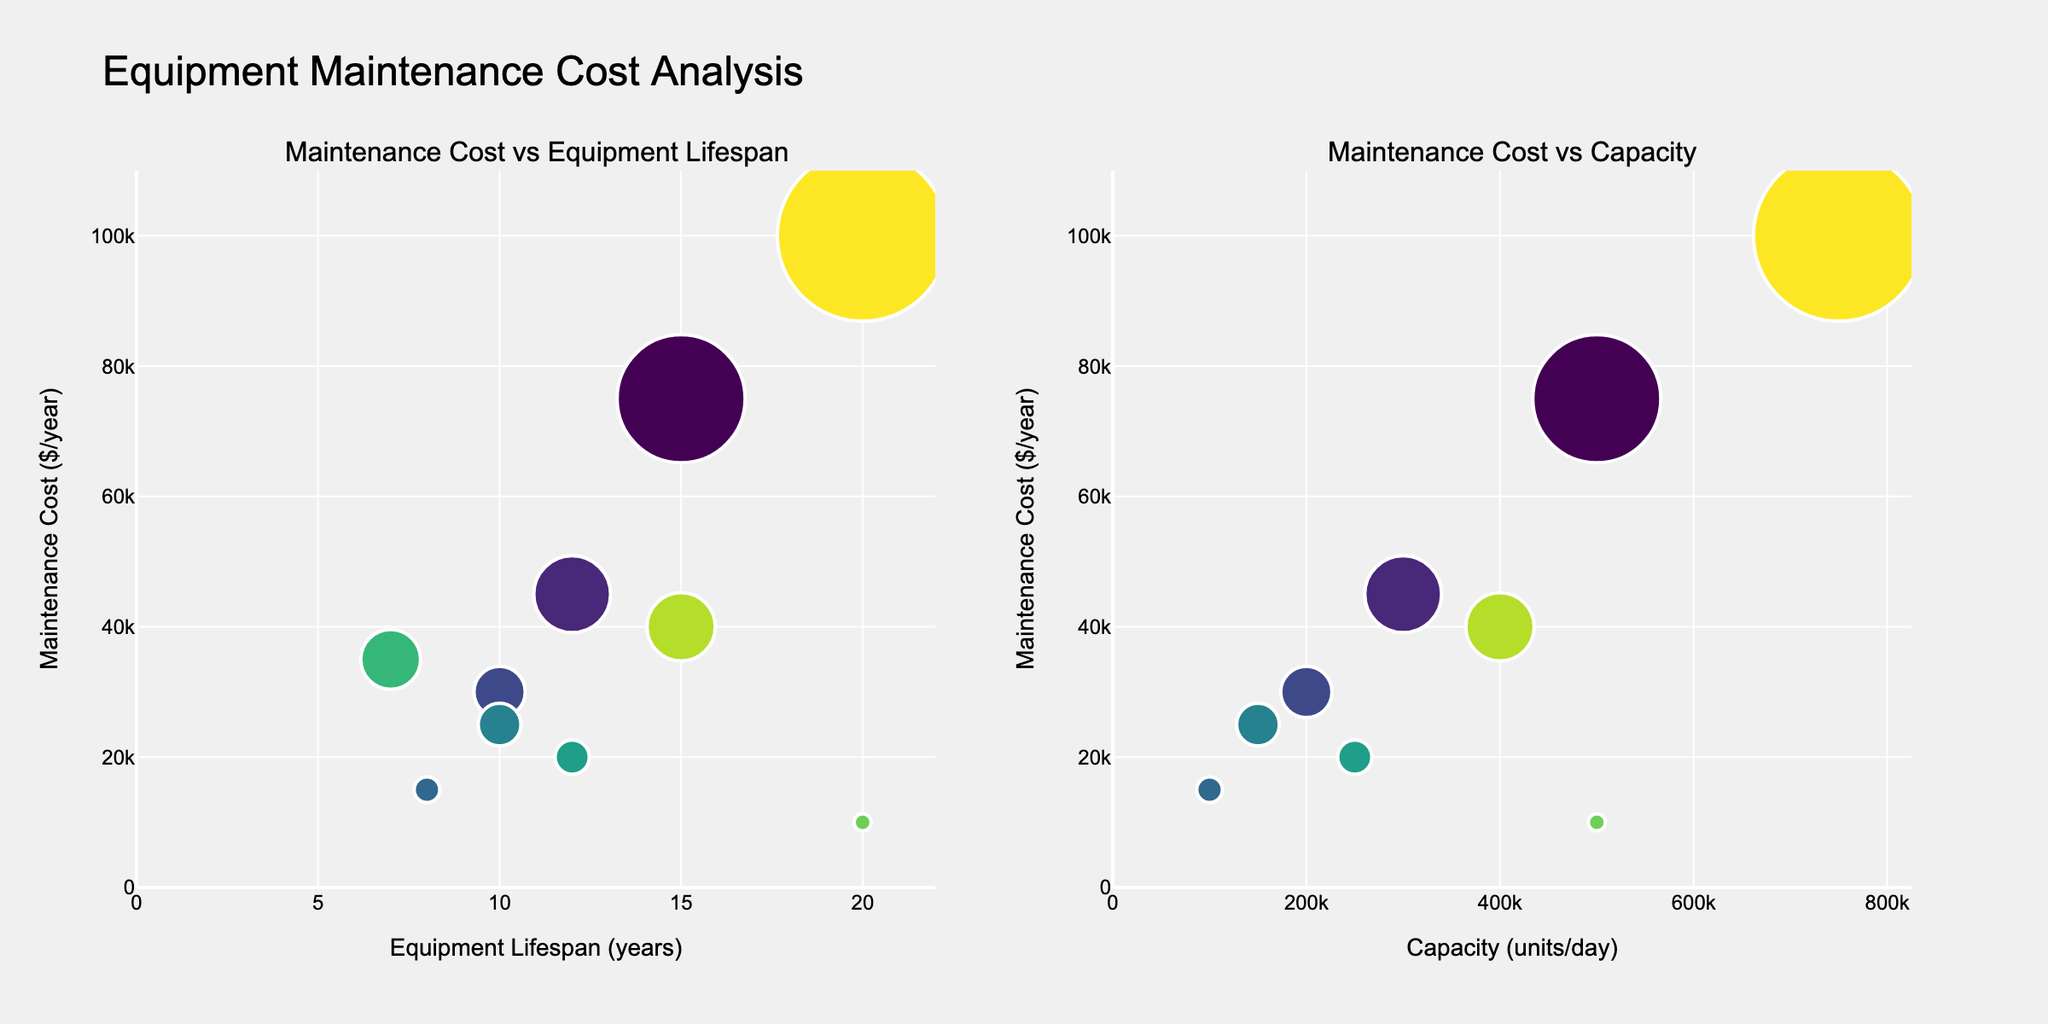What is the title of the figure? The title of the figure is displayed at the top and provides a summary of what the plot is about.
Answer: Mobile Data Consumption Trends by Device Type What is the total mobile data consumption for tablets in 2020 and 2023 combined? From the subplot for tablets, the data consumption in 2020 is 2.3 GB and in 2023 is 3.8 GB. Adding both values gives 2.3 + 3.8 = 6.1 GB.
Answer: 6.1 GB Which device type had the highest data consumption in 2021? By looking at the three subplots for the year 2021, the data consumption values are: Smartphones (6.1 GB), Tablets (2.9 GB), and IoT (1.2 GB). Smartphones have the highest value.
Answer: Smartphones How did smartphone data consumption change from 2019 to 2023? The change in smartphone data consumption from 2019 (3.2 GB) to 2023 (9.6 GB) can be observed by subtracting the earlier value from the later value: 9.6 - 3.2 = 6.4 GB increase.
Answer: Increased by 6.4 GB What is the average data consumption for IoT devices over the 5 years? sum of the data consumption values for IoT devices from 2019 to 2023: 0.5 + 0.8 + 1.2 + 1.7 + 2.3 = 6.5. Dividing by 5 gives the average: 6.5 / 5 = 1.3 GB.
Answer: 1.3 GB Which device type experienced the largest increase in data consumption from 2022 to 2023? By comparing the 2022 values to the 2023 values for each device type, we have: Smartphones (7.8 to 9.6, increase of 1.8 GB), Tablets (3.4 to 3.8, increase of 0.4 GB), IoT (1.7 to 2.3, increase of 0.6 GB). Smartphones had the largest increase.
Answer: Smartphones Is the growth in data consumption for tablets linear or non-linear over the years? From the subplot for tablets, we can observe the year-on-year increments: 1.8 (2019), 2.3 (2020), 2.9 (2021), 3.4 (2022), 3.8 (2023). The increments are not uniform, indicating non-linear growth.
Answer: Non-linear What was the difference in data consumption between smartphones and IoT devices in 2019? The data consumption in 2019 for smartphones is 3.2 GB and for IoT devices is 0.5 GB. The difference is 3.2 - 0.5 = 2.7 GB.
Answer: 2.7 GB Which device type shows a steady increase in data consumption every year? By examining the subplots, smartphones consistently show an increase each year (3.2, 4.5, 6.1, 7.8, 9.6).
Answer: Smartphones 